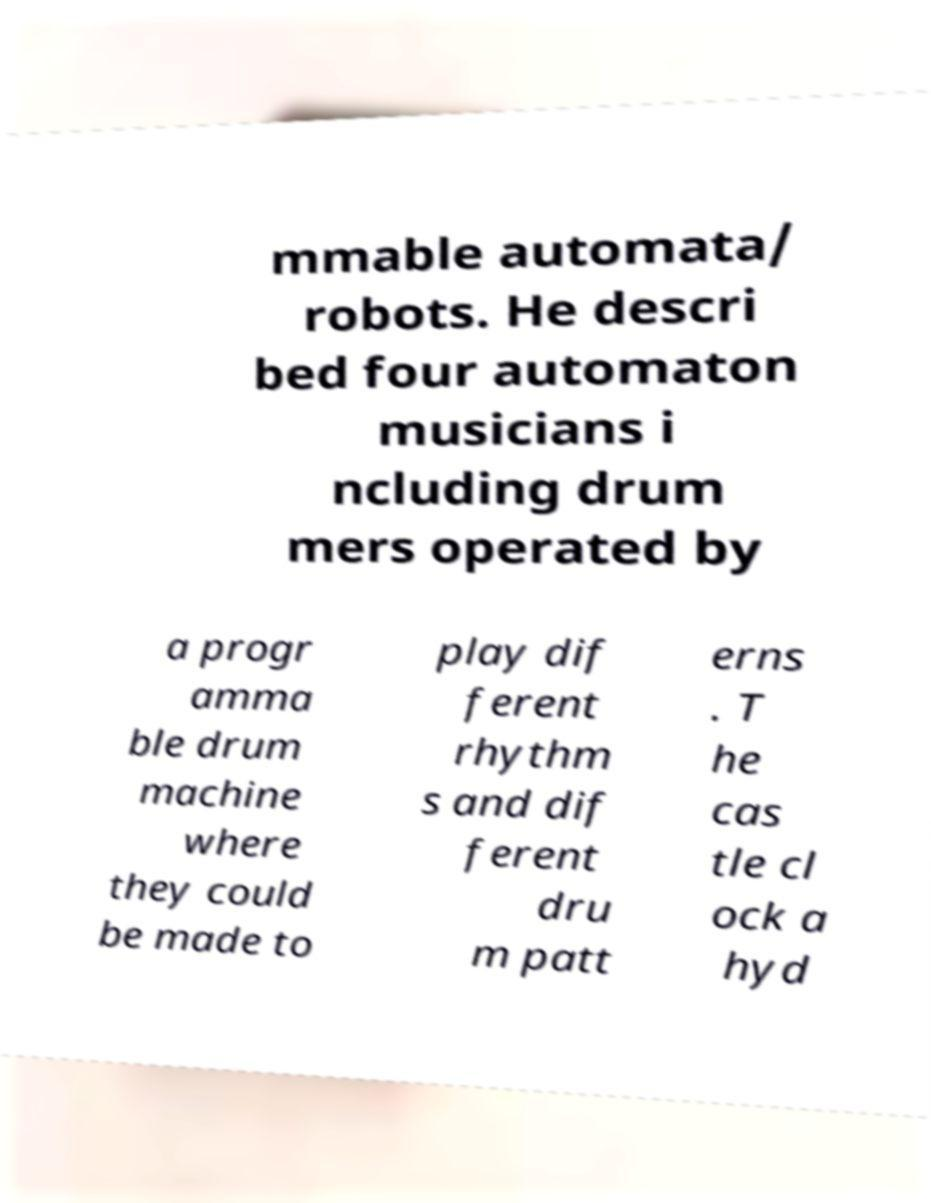For documentation purposes, I need the text within this image transcribed. Could you provide that? mmable automata/ robots. He descri bed four automaton musicians i ncluding drum mers operated by a progr amma ble drum machine where they could be made to play dif ferent rhythm s and dif ferent dru m patt erns . T he cas tle cl ock a hyd 